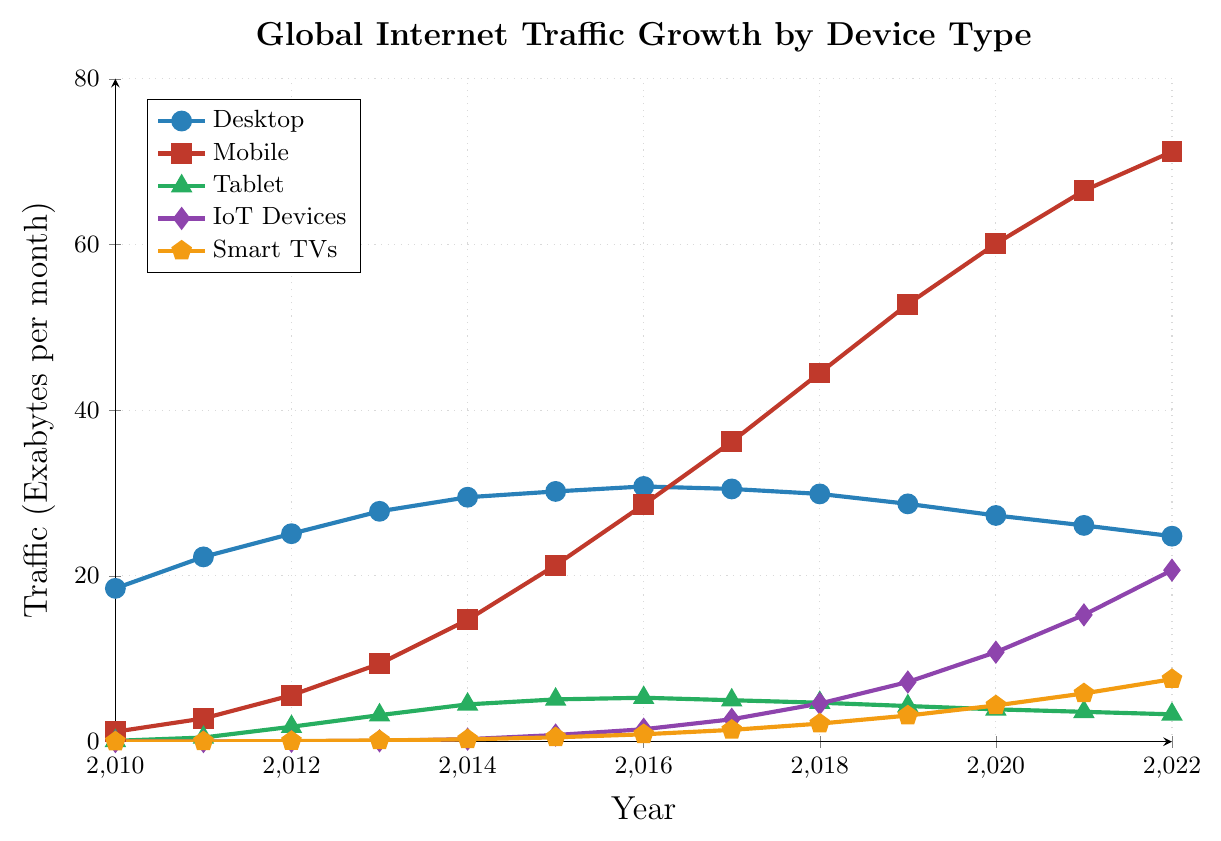What was the percentage increase in mobile internet traffic from 2010 to 2022? To find the percentage increase, subtract the initial value (2010) from the final value (2022), divide the result by the initial value, and multiply by 100: (71.2 - 1.2) / 1.2 * 100 = 5833.33%
Answer: 5833.33% Which device type showed the highest traffic in 2019? By observing the data points for each device type in 2019, Mobile had the highest value with 52.8 Exabytes per month.
Answer: Mobile Between which two consecutive years did IoT Devices experience the largest traffic growth? By checking the difference in IoT traffic between consecutive years, the largest increase is seen from 2021 (15.3) to 2022 (20.7), which is 5.4 Exabytes.
Answer: 2021 and 2022 How did the traffic for tablets change from 2016 to 2019? Tablet traffic decreased from 5.3 Exabytes in 2016 to 4.3 Exabytes in 2019. This is a decrease of (5.3 - 4.3) = 1.0 Exabyte.
Answer: Decreased by 1.0 Exabyte What is the average yearly growth in traffic for Smart TVs between 2010 and 2022? To calculate the average yearly growth, find the total growth over the period and divide by the number of years: (7.54 - 0.01) / (2022 - 2010) = 7.53 / 12 = 0.6275 Exabytes per year.
Answer: 0.6275 Exabytes per year Compare the traffic for Desktop in 2012 with Mobile in 2022 in terms of percentage. Mobile traffic in 2022 (71.2) is significantly higher than Desktop traffic in 2012 (25.1). The percentage is (71.2 / 25.1) * 100 = 283.27%.
Answer: 283.27% What year did Mobile internet traffic surpass Desktop internet traffic? By observing the figure, Mobile internet traffic surpassed Desktop internet traffic between 2014 and 2015, with 2015 being the first year Mobile traffic (21.3) exceeded Desktop traffic (30.2). Therefore, the cross-over occurred by 2015.
Answer: 2015 Which device type had the steadiest growth over the entire period? By observing the slopes of the lines for each device type in the figure, IoT Devices showed a gradual and increasing growth without any dips or sharp spikes.
Answer: IoT Devices 